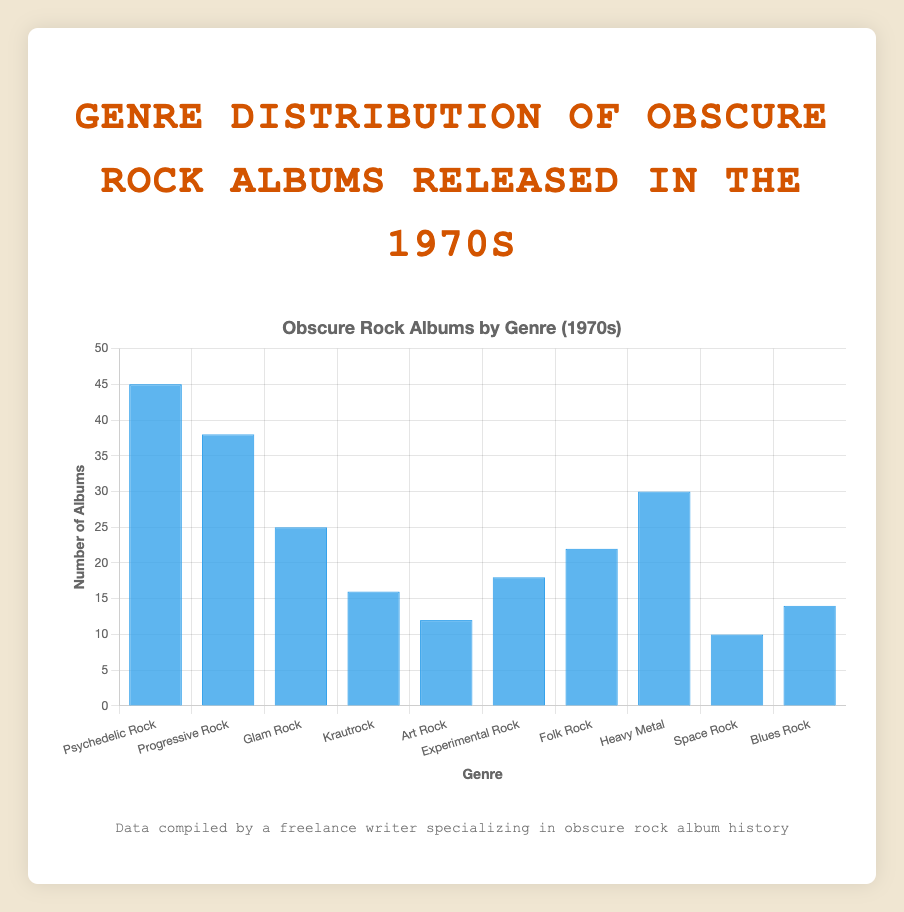Which genre has the highest number of albums? The bar for "Psychedelic Rock" is the tallest, indicating it has the highest number of albums.
Answer: Psychedelic Rock How many more albums does Psychedelic Rock have compared to Krautrock? The number of albums for Psychedelic Rock is 45, and for Krautrock, it is 16. The difference is 45 - 16.
Answer: 29 What is the total number of albums for Progressive Rock and Heavy Metal combined? The number of albums for Progressive Rock is 38, and for Heavy Metal, it is 30. The total is 38 + 30.
Answer: 68 Which genre has the smallest number of albums? The bar for "Space Rock" is the shortest, indicating it has the smallest number of albums.
Answer: Space Rock How many genres have more than 20 albums? The genres with more than 20 albums are Psychedelic Rock (45), Progressive Rock (38), Glam Rock (25), Heavy Metal (30), and Folk Rock (22). So, there are 5 genres.
Answer: 5 Which genre has more albums: Art Rock or Experimental Rock? The number of albums for Art Rock is 12, and for Experimental Rock, it is 18. Experimental Rock has more albums.
Answer: Experimental Rock What is the average number of albums across all genres? The total number of albums is the sum of all albums: 45 + 38 + 25 + 16 + 12 + 18 + 22 + 30 + 10 + 14 = 230. There are 10 genres, so the average is 230 / 10.
Answer: 23 How many albums are there in total for the genres with fewer than 15 albums? The genres with fewer than 15 albums are Krautrock (16), Art Rock (12), Space Rock (10), and Blues Rock (14). The total is 12 + 10 + 14.
Answer: 36 Is the number of albums in Folk Rock closer to Heavy Metal or Experimental Rock? Folk Rock has 22 albums. Heavy Metal has 30 albums (difference of 30 - 22 = 8), and Experimental Rock has 18 albums (difference of 22 - 18 = 4). The difference is smaller for Experimental Rock.
Answer: Experimental Rock What is the combined number of albums for the three least represented genres? The three least represented genres are Space Rock (10), Art Rock (12), and Blues Rock (14). The combined number is 10 + 12 + 14.
Answer: 36 